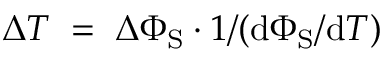<formula> <loc_0><loc_0><loc_500><loc_500>\Delta T \, = \, \Delta \Phi _ { S } \cdot 1 / ( d \Phi _ { S } / d T )</formula> 